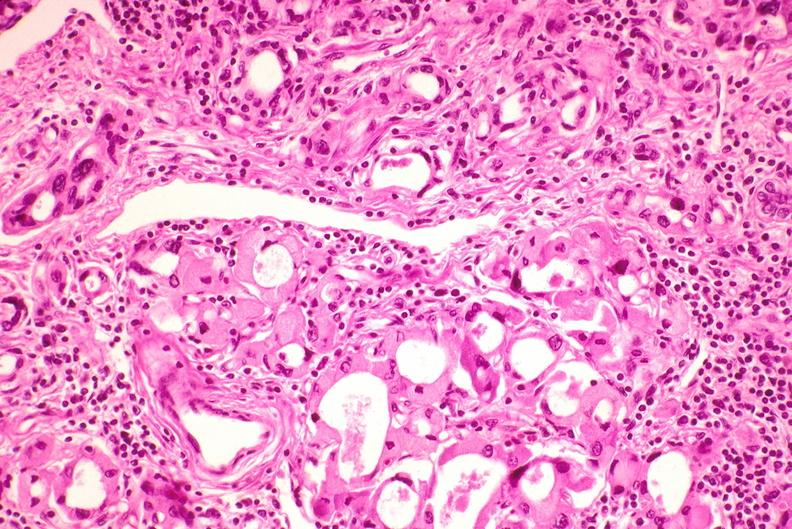s anencephaly present?
Answer the question using a single word or phrase. No 